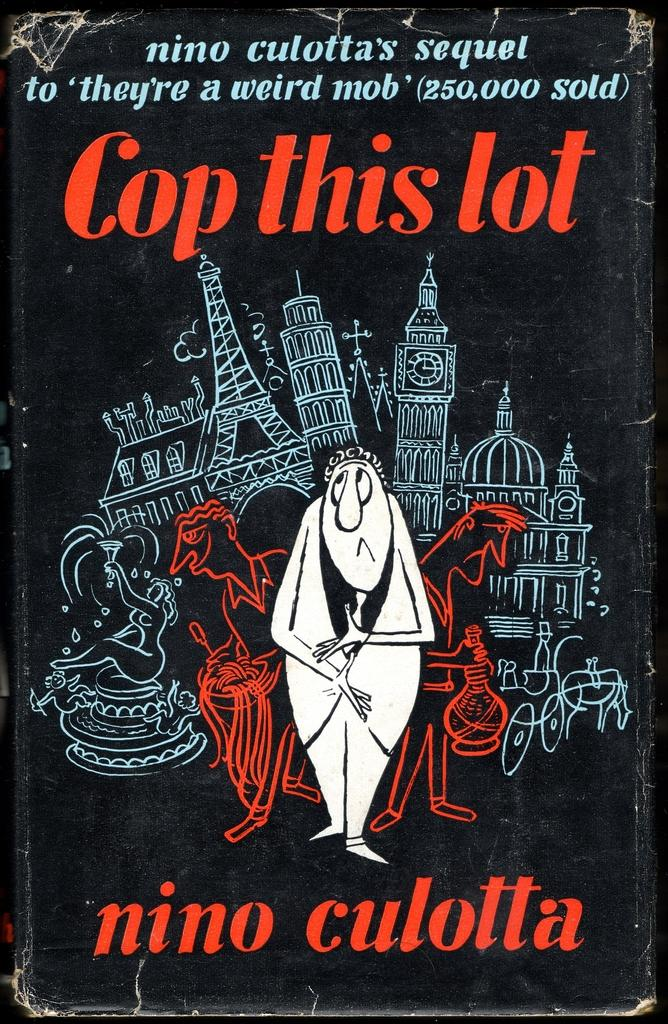What type of visual representation is shown in the image? The image is a poster. What kind of structures are depicted in the poster? There are buildings depicted in the poster. What mode of transportation can be seen in the poster? A horse cart is present in the poster. Are there any human figures in the poster? Yes, there are people in the poster. What else is featured on the poster besides the visual elements? There is text on the poster. Who created the pizzas depicted in the poster? There are no pizzas depicted in the poster, so there is no creator to mention. What type of border surrounds the poster? The provided facts do not mention any border surrounding the poster, so it cannot be described. 